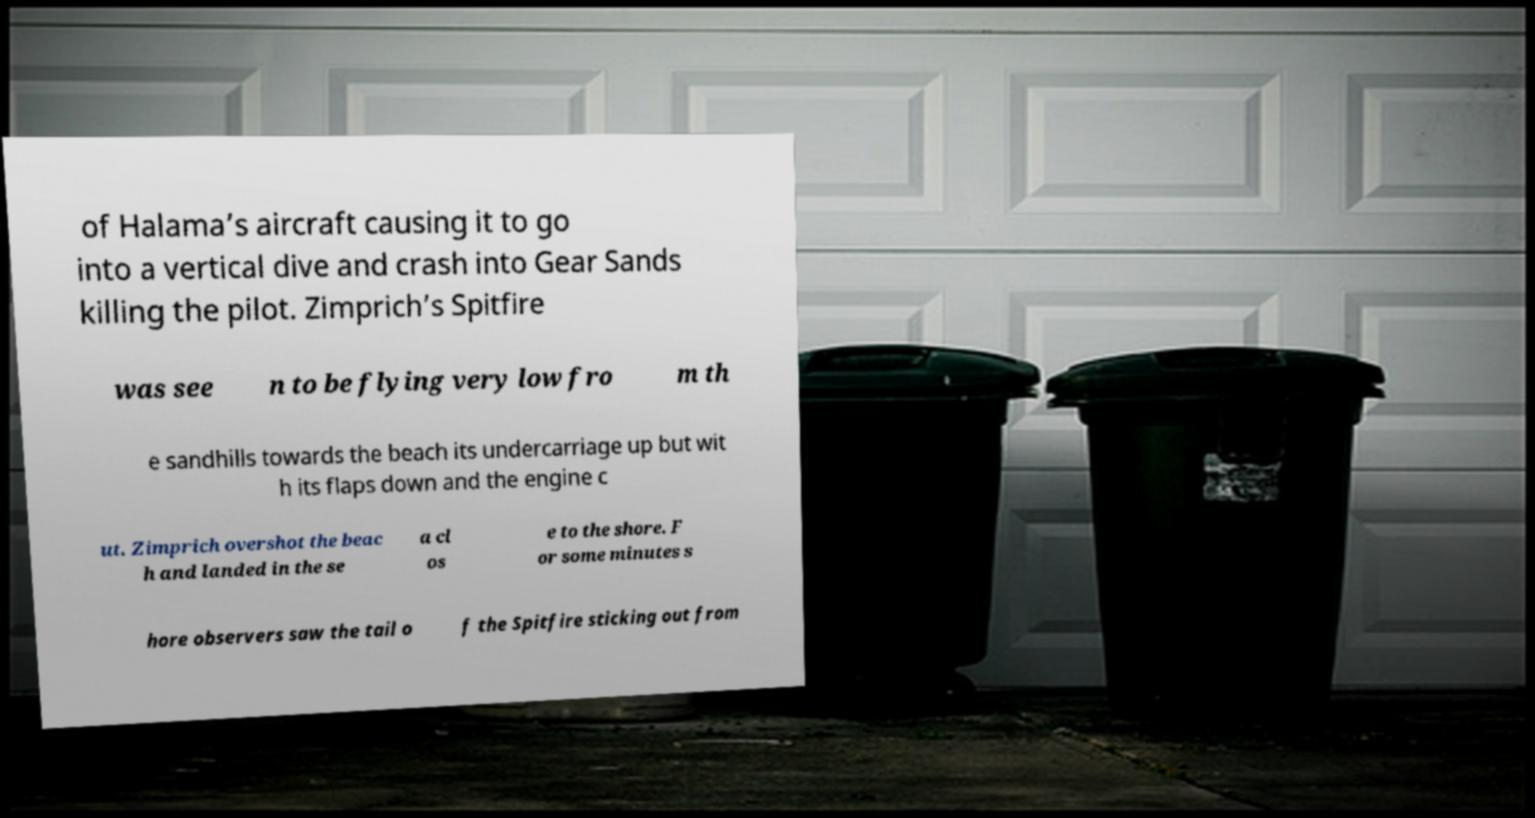For documentation purposes, I need the text within this image transcribed. Could you provide that? of Halama’s aircraft causing it to go into a vertical dive and crash into Gear Sands killing the pilot. Zimprich’s Spitfire was see n to be flying very low fro m th e sandhills towards the beach its undercarriage up but wit h its flaps down and the engine c ut. Zimprich overshot the beac h and landed in the se a cl os e to the shore. F or some minutes s hore observers saw the tail o f the Spitfire sticking out from 